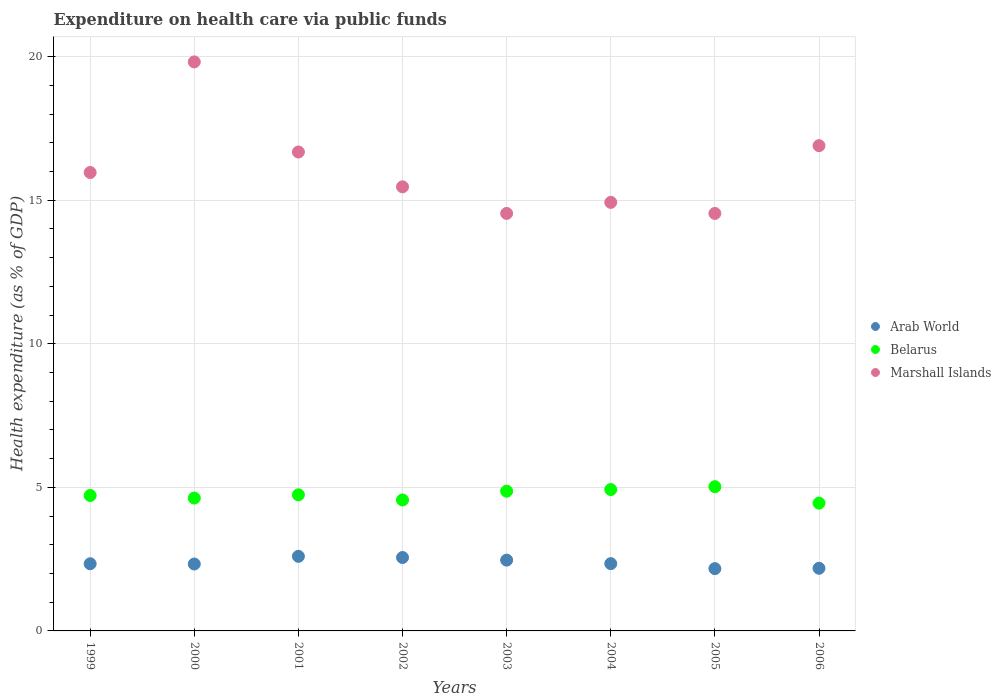How many different coloured dotlines are there?
Offer a terse response. 3. What is the expenditure made on health care in Marshall Islands in 2003?
Your answer should be very brief. 14.54. Across all years, what is the maximum expenditure made on health care in Belarus?
Offer a very short reply. 5.02. Across all years, what is the minimum expenditure made on health care in Belarus?
Ensure brevity in your answer.  4.45. In which year was the expenditure made on health care in Belarus maximum?
Your response must be concise. 2005. What is the total expenditure made on health care in Arab World in the graph?
Make the answer very short. 18.98. What is the difference between the expenditure made on health care in Arab World in 2005 and that in 2006?
Offer a very short reply. -0.01. What is the difference between the expenditure made on health care in Arab World in 2002 and the expenditure made on health care in Marshall Islands in 2001?
Your answer should be very brief. -14.12. What is the average expenditure made on health care in Arab World per year?
Offer a very short reply. 2.37. In the year 2004, what is the difference between the expenditure made on health care in Belarus and expenditure made on health care in Arab World?
Your answer should be very brief. 2.58. What is the ratio of the expenditure made on health care in Belarus in 2000 to that in 2004?
Provide a short and direct response. 0.94. What is the difference between the highest and the second highest expenditure made on health care in Belarus?
Keep it short and to the point. 0.1. What is the difference between the highest and the lowest expenditure made on health care in Arab World?
Offer a very short reply. 0.43. In how many years, is the expenditure made on health care in Belarus greater than the average expenditure made on health care in Belarus taken over all years?
Your response must be concise. 4. Is it the case that in every year, the sum of the expenditure made on health care in Arab World and expenditure made on health care in Belarus  is greater than the expenditure made on health care in Marshall Islands?
Offer a terse response. No. Is the expenditure made on health care in Marshall Islands strictly greater than the expenditure made on health care in Arab World over the years?
Give a very brief answer. Yes. Is the expenditure made on health care in Belarus strictly less than the expenditure made on health care in Marshall Islands over the years?
Give a very brief answer. Yes. How many dotlines are there?
Provide a succinct answer. 3. Are the values on the major ticks of Y-axis written in scientific E-notation?
Keep it short and to the point. No. Does the graph contain any zero values?
Your response must be concise. No. Does the graph contain grids?
Provide a short and direct response. Yes. Where does the legend appear in the graph?
Give a very brief answer. Center right. How many legend labels are there?
Keep it short and to the point. 3. What is the title of the graph?
Offer a very short reply. Expenditure on health care via public funds. Does "Norway" appear as one of the legend labels in the graph?
Give a very brief answer. No. What is the label or title of the X-axis?
Your response must be concise. Years. What is the label or title of the Y-axis?
Your answer should be very brief. Health expenditure (as % of GDP). What is the Health expenditure (as % of GDP) of Arab World in 1999?
Make the answer very short. 2.34. What is the Health expenditure (as % of GDP) of Belarus in 1999?
Provide a succinct answer. 4.72. What is the Health expenditure (as % of GDP) in Marshall Islands in 1999?
Offer a very short reply. 15.96. What is the Health expenditure (as % of GDP) of Arab World in 2000?
Offer a very short reply. 2.33. What is the Health expenditure (as % of GDP) in Belarus in 2000?
Offer a very short reply. 4.63. What is the Health expenditure (as % of GDP) in Marshall Islands in 2000?
Keep it short and to the point. 19.81. What is the Health expenditure (as % of GDP) of Arab World in 2001?
Make the answer very short. 2.6. What is the Health expenditure (as % of GDP) of Belarus in 2001?
Your response must be concise. 4.74. What is the Health expenditure (as % of GDP) of Marshall Islands in 2001?
Keep it short and to the point. 16.68. What is the Health expenditure (as % of GDP) of Arab World in 2002?
Give a very brief answer. 2.56. What is the Health expenditure (as % of GDP) in Belarus in 2002?
Make the answer very short. 4.56. What is the Health expenditure (as % of GDP) of Marshall Islands in 2002?
Your response must be concise. 15.46. What is the Health expenditure (as % of GDP) of Arab World in 2003?
Provide a succinct answer. 2.47. What is the Health expenditure (as % of GDP) in Belarus in 2003?
Offer a terse response. 4.87. What is the Health expenditure (as % of GDP) of Marshall Islands in 2003?
Make the answer very short. 14.54. What is the Health expenditure (as % of GDP) of Arab World in 2004?
Ensure brevity in your answer.  2.34. What is the Health expenditure (as % of GDP) of Belarus in 2004?
Your answer should be very brief. 4.92. What is the Health expenditure (as % of GDP) of Marshall Islands in 2004?
Your answer should be compact. 14.92. What is the Health expenditure (as % of GDP) of Arab World in 2005?
Provide a short and direct response. 2.17. What is the Health expenditure (as % of GDP) in Belarus in 2005?
Provide a succinct answer. 5.02. What is the Health expenditure (as % of GDP) of Marshall Islands in 2005?
Your answer should be very brief. 14.54. What is the Health expenditure (as % of GDP) of Arab World in 2006?
Your answer should be very brief. 2.18. What is the Health expenditure (as % of GDP) of Belarus in 2006?
Your answer should be compact. 4.45. What is the Health expenditure (as % of GDP) of Marshall Islands in 2006?
Make the answer very short. 16.9. Across all years, what is the maximum Health expenditure (as % of GDP) of Arab World?
Offer a very short reply. 2.6. Across all years, what is the maximum Health expenditure (as % of GDP) in Belarus?
Ensure brevity in your answer.  5.02. Across all years, what is the maximum Health expenditure (as % of GDP) of Marshall Islands?
Make the answer very short. 19.81. Across all years, what is the minimum Health expenditure (as % of GDP) in Arab World?
Keep it short and to the point. 2.17. Across all years, what is the minimum Health expenditure (as % of GDP) in Belarus?
Provide a short and direct response. 4.45. Across all years, what is the minimum Health expenditure (as % of GDP) in Marshall Islands?
Offer a terse response. 14.54. What is the total Health expenditure (as % of GDP) of Arab World in the graph?
Provide a succinct answer. 18.98. What is the total Health expenditure (as % of GDP) of Belarus in the graph?
Your answer should be very brief. 37.9. What is the total Health expenditure (as % of GDP) of Marshall Islands in the graph?
Your answer should be very brief. 128.82. What is the difference between the Health expenditure (as % of GDP) in Arab World in 1999 and that in 2000?
Offer a terse response. 0.01. What is the difference between the Health expenditure (as % of GDP) of Belarus in 1999 and that in 2000?
Keep it short and to the point. 0.09. What is the difference between the Health expenditure (as % of GDP) in Marshall Islands in 1999 and that in 2000?
Offer a terse response. -3.85. What is the difference between the Health expenditure (as % of GDP) in Arab World in 1999 and that in 2001?
Make the answer very short. -0.26. What is the difference between the Health expenditure (as % of GDP) in Belarus in 1999 and that in 2001?
Your answer should be very brief. -0.02. What is the difference between the Health expenditure (as % of GDP) in Marshall Islands in 1999 and that in 2001?
Provide a short and direct response. -0.71. What is the difference between the Health expenditure (as % of GDP) in Arab World in 1999 and that in 2002?
Your answer should be very brief. -0.22. What is the difference between the Health expenditure (as % of GDP) in Belarus in 1999 and that in 2002?
Offer a very short reply. 0.16. What is the difference between the Health expenditure (as % of GDP) in Marshall Islands in 1999 and that in 2002?
Offer a terse response. 0.5. What is the difference between the Health expenditure (as % of GDP) of Arab World in 1999 and that in 2003?
Offer a terse response. -0.13. What is the difference between the Health expenditure (as % of GDP) of Marshall Islands in 1999 and that in 2003?
Offer a very short reply. 1.43. What is the difference between the Health expenditure (as % of GDP) in Arab World in 1999 and that in 2004?
Give a very brief answer. -0. What is the difference between the Health expenditure (as % of GDP) in Belarus in 1999 and that in 2004?
Give a very brief answer. -0.21. What is the difference between the Health expenditure (as % of GDP) in Marshall Islands in 1999 and that in 2004?
Give a very brief answer. 1.04. What is the difference between the Health expenditure (as % of GDP) of Arab World in 1999 and that in 2005?
Ensure brevity in your answer.  0.17. What is the difference between the Health expenditure (as % of GDP) in Belarus in 1999 and that in 2005?
Provide a succinct answer. -0.31. What is the difference between the Health expenditure (as % of GDP) of Marshall Islands in 1999 and that in 2005?
Your answer should be compact. 1.43. What is the difference between the Health expenditure (as % of GDP) in Arab World in 1999 and that in 2006?
Offer a very short reply. 0.16. What is the difference between the Health expenditure (as % of GDP) in Belarus in 1999 and that in 2006?
Give a very brief answer. 0.27. What is the difference between the Health expenditure (as % of GDP) in Marshall Islands in 1999 and that in 2006?
Your answer should be compact. -0.93. What is the difference between the Health expenditure (as % of GDP) of Arab World in 2000 and that in 2001?
Your answer should be very brief. -0.27. What is the difference between the Health expenditure (as % of GDP) of Belarus in 2000 and that in 2001?
Keep it short and to the point. -0.11. What is the difference between the Health expenditure (as % of GDP) of Marshall Islands in 2000 and that in 2001?
Keep it short and to the point. 3.14. What is the difference between the Health expenditure (as % of GDP) in Arab World in 2000 and that in 2002?
Provide a short and direct response. -0.23. What is the difference between the Health expenditure (as % of GDP) of Belarus in 2000 and that in 2002?
Give a very brief answer. 0.07. What is the difference between the Health expenditure (as % of GDP) in Marshall Islands in 2000 and that in 2002?
Give a very brief answer. 4.35. What is the difference between the Health expenditure (as % of GDP) in Arab World in 2000 and that in 2003?
Ensure brevity in your answer.  -0.14. What is the difference between the Health expenditure (as % of GDP) in Belarus in 2000 and that in 2003?
Give a very brief answer. -0.24. What is the difference between the Health expenditure (as % of GDP) of Marshall Islands in 2000 and that in 2003?
Your answer should be very brief. 5.28. What is the difference between the Health expenditure (as % of GDP) of Arab World in 2000 and that in 2004?
Give a very brief answer. -0.01. What is the difference between the Health expenditure (as % of GDP) in Belarus in 2000 and that in 2004?
Your answer should be very brief. -0.3. What is the difference between the Health expenditure (as % of GDP) of Marshall Islands in 2000 and that in 2004?
Make the answer very short. 4.89. What is the difference between the Health expenditure (as % of GDP) in Arab World in 2000 and that in 2005?
Ensure brevity in your answer.  0.16. What is the difference between the Health expenditure (as % of GDP) of Belarus in 2000 and that in 2005?
Your answer should be compact. -0.4. What is the difference between the Health expenditure (as % of GDP) in Marshall Islands in 2000 and that in 2005?
Ensure brevity in your answer.  5.28. What is the difference between the Health expenditure (as % of GDP) of Arab World in 2000 and that in 2006?
Keep it short and to the point. 0.15. What is the difference between the Health expenditure (as % of GDP) of Belarus in 2000 and that in 2006?
Your response must be concise. 0.18. What is the difference between the Health expenditure (as % of GDP) of Marshall Islands in 2000 and that in 2006?
Your answer should be compact. 2.92. What is the difference between the Health expenditure (as % of GDP) in Arab World in 2001 and that in 2002?
Give a very brief answer. 0.04. What is the difference between the Health expenditure (as % of GDP) in Belarus in 2001 and that in 2002?
Your answer should be very brief. 0.18. What is the difference between the Health expenditure (as % of GDP) in Marshall Islands in 2001 and that in 2002?
Provide a short and direct response. 1.21. What is the difference between the Health expenditure (as % of GDP) of Arab World in 2001 and that in 2003?
Offer a very short reply. 0.13. What is the difference between the Health expenditure (as % of GDP) in Belarus in 2001 and that in 2003?
Keep it short and to the point. -0.13. What is the difference between the Health expenditure (as % of GDP) of Marshall Islands in 2001 and that in 2003?
Your answer should be compact. 2.14. What is the difference between the Health expenditure (as % of GDP) of Arab World in 2001 and that in 2004?
Give a very brief answer. 0.25. What is the difference between the Health expenditure (as % of GDP) of Belarus in 2001 and that in 2004?
Offer a terse response. -0.18. What is the difference between the Health expenditure (as % of GDP) of Marshall Islands in 2001 and that in 2004?
Make the answer very short. 1.75. What is the difference between the Health expenditure (as % of GDP) in Arab World in 2001 and that in 2005?
Provide a succinct answer. 0.43. What is the difference between the Health expenditure (as % of GDP) of Belarus in 2001 and that in 2005?
Ensure brevity in your answer.  -0.28. What is the difference between the Health expenditure (as % of GDP) of Marshall Islands in 2001 and that in 2005?
Ensure brevity in your answer.  2.14. What is the difference between the Health expenditure (as % of GDP) of Arab World in 2001 and that in 2006?
Your answer should be very brief. 0.42. What is the difference between the Health expenditure (as % of GDP) of Belarus in 2001 and that in 2006?
Offer a very short reply. 0.29. What is the difference between the Health expenditure (as % of GDP) of Marshall Islands in 2001 and that in 2006?
Give a very brief answer. -0.22. What is the difference between the Health expenditure (as % of GDP) of Arab World in 2002 and that in 2003?
Keep it short and to the point. 0.09. What is the difference between the Health expenditure (as % of GDP) of Belarus in 2002 and that in 2003?
Provide a short and direct response. -0.31. What is the difference between the Health expenditure (as % of GDP) of Marshall Islands in 2002 and that in 2003?
Ensure brevity in your answer.  0.93. What is the difference between the Health expenditure (as % of GDP) in Arab World in 2002 and that in 2004?
Keep it short and to the point. 0.21. What is the difference between the Health expenditure (as % of GDP) in Belarus in 2002 and that in 2004?
Your response must be concise. -0.36. What is the difference between the Health expenditure (as % of GDP) of Marshall Islands in 2002 and that in 2004?
Your answer should be very brief. 0.54. What is the difference between the Health expenditure (as % of GDP) of Arab World in 2002 and that in 2005?
Make the answer very short. 0.39. What is the difference between the Health expenditure (as % of GDP) of Belarus in 2002 and that in 2005?
Give a very brief answer. -0.46. What is the difference between the Health expenditure (as % of GDP) in Marshall Islands in 2002 and that in 2005?
Make the answer very short. 0.93. What is the difference between the Health expenditure (as % of GDP) of Arab World in 2002 and that in 2006?
Provide a succinct answer. 0.38. What is the difference between the Health expenditure (as % of GDP) of Belarus in 2002 and that in 2006?
Give a very brief answer. 0.11. What is the difference between the Health expenditure (as % of GDP) in Marshall Islands in 2002 and that in 2006?
Keep it short and to the point. -1.43. What is the difference between the Health expenditure (as % of GDP) in Arab World in 2003 and that in 2004?
Give a very brief answer. 0.12. What is the difference between the Health expenditure (as % of GDP) of Belarus in 2003 and that in 2004?
Your answer should be compact. -0.06. What is the difference between the Health expenditure (as % of GDP) of Marshall Islands in 2003 and that in 2004?
Keep it short and to the point. -0.38. What is the difference between the Health expenditure (as % of GDP) in Arab World in 2003 and that in 2005?
Offer a terse response. 0.3. What is the difference between the Health expenditure (as % of GDP) in Belarus in 2003 and that in 2005?
Offer a very short reply. -0.16. What is the difference between the Health expenditure (as % of GDP) of Marshall Islands in 2003 and that in 2005?
Give a very brief answer. -0. What is the difference between the Health expenditure (as % of GDP) in Arab World in 2003 and that in 2006?
Offer a terse response. 0.28. What is the difference between the Health expenditure (as % of GDP) of Belarus in 2003 and that in 2006?
Make the answer very short. 0.42. What is the difference between the Health expenditure (as % of GDP) of Marshall Islands in 2003 and that in 2006?
Provide a succinct answer. -2.36. What is the difference between the Health expenditure (as % of GDP) of Arab World in 2004 and that in 2005?
Your answer should be very brief. 0.17. What is the difference between the Health expenditure (as % of GDP) of Belarus in 2004 and that in 2005?
Ensure brevity in your answer.  -0.1. What is the difference between the Health expenditure (as % of GDP) of Marshall Islands in 2004 and that in 2005?
Give a very brief answer. 0.38. What is the difference between the Health expenditure (as % of GDP) in Arab World in 2004 and that in 2006?
Give a very brief answer. 0.16. What is the difference between the Health expenditure (as % of GDP) in Belarus in 2004 and that in 2006?
Offer a very short reply. 0.47. What is the difference between the Health expenditure (as % of GDP) of Marshall Islands in 2004 and that in 2006?
Keep it short and to the point. -1.97. What is the difference between the Health expenditure (as % of GDP) of Arab World in 2005 and that in 2006?
Provide a short and direct response. -0.01. What is the difference between the Health expenditure (as % of GDP) in Belarus in 2005 and that in 2006?
Ensure brevity in your answer.  0.57. What is the difference between the Health expenditure (as % of GDP) of Marshall Islands in 2005 and that in 2006?
Your response must be concise. -2.36. What is the difference between the Health expenditure (as % of GDP) of Arab World in 1999 and the Health expenditure (as % of GDP) of Belarus in 2000?
Your answer should be compact. -2.29. What is the difference between the Health expenditure (as % of GDP) in Arab World in 1999 and the Health expenditure (as % of GDP) in Marshall Islands in 2000?
Offer a very short reply. -17.48. What is the difference between the Health expenditure (as % of GDP) of Belarus in 1999 and the Health expenditure (as % of GDP) of Marshall Islands in 2000?
Provide a succinct answer. -15.1. What is the difference between the Health expenditure (as % of GDP) in Arab World in 1999 and the Health expenditure (as % of GDP) in Belarus in 2001?
Provide a succinct answer. -2.4. What is the difference between the Health expenditure (as % of GDP) of Arab World in 1999 and the Health expenditure (as % of GDP) of Marshall Islands in 2001?
Make the answer very short. -14.34. What is the difference between the Health expenditure (as % of GDP) of Belarus in 1999 and the Health expenditure (as % of GDP) of Marshall Islands in 2001?
Provide a short and direct response. -11.96. What is the difference between the Health expenditure (as % of GDP) in Arab World in 1999 and the Health expenditure (as % of GDP) in Belarus in 2002?
Offer a terse response. -2.22. What is the difference between the Health expenditure (as % of GDP) of Arab World in 1999 and the Health expenditure (as % of GDP) of Marshall Islands in 2002?
Offer a very short reply. -13.13. What is the difference between the Health expenditure (as % of GDP) of Belarus in 1999 and the Health expenditure (as % of GDP) of Marshall Islands in 2002?
Provide a short and direct response. -10.75. What is the difference between the Health expenditure (as % of GDP) of Arab World in 1999 and the Health expenditure (as % of GDP) of Belarus in 2003?
Provide a short and direct response. -2.53. What is the difference between the Health expenditure (as % of GDP) of Arab World in 1999 and the Health expenditure (as % of GDP) of Marshall Islands in 2003?
Offer a very short reply. -12.2. What is the difference between the Health expenditure (as % of GDP) in Belarus in 1999 and the Health expenditure (as % of GDP) in Marshall Islands in 2003?
Your response must be concise. -9.82. What is the difference between the Health expenditure (as % of GDP) of Arab World in 1999 and the Health expenditure (as % of GDP) of Belarus in 2004?
Offer a terse response. -2.58. What is the difference between the Health expenditure (as % of GDP) in Arab World in 1999 and the Health expenditure (as % of GDP) in Marshall Islands in 2004?
Your response must be concise. -12.58. What is the difference between the Health expenditure (as % of GDP) of Belarus in 1999 and the Health expenditure (as % of GDP) of Marshall Islands in 2004?
Keep it short and to the point. -10.21. What is the difference between the Health expenditure (as % of GDP) in Arab World in 1999 and the Health expenditure (as % of GDP) in Belarus in 2005?
Provide a short and direct response. -2.68. What is the difference between the Health expenditure (as % of GDP) of Arab World in 1999 and the Health expenditure (as % of GDP) of Marshall Islands in 2005?
Keep it short and to the point. -12.2. What is the difference between the Health expenditure (as % of GDP) in Belarus in 1999 and the Health expenditure (as % of GDP) in Marshall Islands in 2005?
Give a very brief answer. -9.82. What is the difference between the Health expenditure (as % of GDP) in Arab World in 1999 and the Health expenditure (as % of GDP) in Belarus in 2006?
Your response must be concise. -2.11. What is the difference between the Health expenditure (as % of GDP) of Arab World in 1999 and the Health expenditure (as % of GDP) of Marshall Islands in 2006?
Keep it short and to the point. -14.56. What is the difference between the Health expenditure (as % of GDP) in Belarus in 1999 and the Health expenditure (as % of GDP) in Marshall Islands in 2006?
Provide a succinct answer. -12.18. What is the difference between the Health expenditure (as % of GDP) of Arab World in 2000 and the Health expenditure (as % of GDP) of Belarus in 2001?
Your answer should be very brief. -2.41. What is the difference between the Health expenditure (as % of GDP) in Arab World in 2000 and the Health expenditure (as % of GDP) in Marshall Islands in 2001?
Give a very brief answer. -14.35. What is the difference between the Health expenditure (as % of GDP) of Belarus in 2000 and the Health expenditure (as % of GDP) of Marshall Islands in 2001?
Make the answer very short. -12.05. What is the difference between the Health expenditure (as % of GDP) of Arab World in 2000 and the Health expenditure (as % of GDP) of Belarus in 2002?
Keep it short and to the point. -2.23. What is the difference between the Health expenditure (as % of GDP) in Arab World in 2000 and the Health expenditure (as % of GDP) in Marshall Islands in 2002?
Your answer should be very brief. -13.13. What is the difference between the Health expenditure (as % of GDP) of Belarus in 2000 and the Health expenditure (as % of GDP) of Marshall Islands in 2002?
Offer a very short reply. -10.84. What is the difference between the Health expenditure (as % of GDP) of Arab World in 2000 and the Health expenditure (as % of GDP) of Belarus in 2003?
Provide a succinct answer. -2.54. What is the difference between the Health expenditure (as % of GDP) of Arab World in 2000 and the Health expenditure (as % of GDP) of Marshall Islands in 2003?
Provide a succinct answer. -12.21. What is the difference between the Health expenditure (as % of GDP) of Belarus in 2000 and the Health expenditure (as % of GDP) of Marshall Islands in 2003?
Make the answer very short. -9.91. What is the difference between the Health expenditure (as % of GDP) of Arab World in 2000 and the Health expenditure (as % of GDP) of Belarus in 2004?
Offer a very short reply. -2.59. What is the difference between the Health expenditure (as % of GDP) in Arab World in 2000 and the Health expenditure (as % of GDP) in Marshall Islands in 2004?
Offer a very short reply. -12.59. What is the difference between the Health expenditure (as % of GDP) of Belarus in 2000 and the Health expenditure (as % of GDP) of Marshall Islands in 2004?
Provide a short and direct response. -10.3. What is the difference between the Health expenditure (as % of GDP) in Arab World in 2000 and the Health expenditure (as % of GDP) in Belarus in 2005?
Offer a very short reply. -2.69. What is the difference between the Health expenditure (as % of GDP) of Arab World in 2000 and the Health expenditure (as % of GDP) of Marshall Islands in 2005?
Provide a short and direct response. -12.21. What is the difference between the Health expenditure (as % of GDP) in Belarus in 2000 and the Health expenditure (as % of GDP) in Marshall Islands in 2005?
Make the answer very short. -9.91. What is the difference between the Health expenditure (as % of GDP) in Arab World in 2000 and the Health expenditure (as % of GDP) in Belarus in 2006?
Offer a very short reply. -2.12. What is the difference between the Health expenditure (as % of GDP) in Arab World in 2000 and the Health expenditure (as % of GDP) in Marshall Islands in 2006?
Ensure brevity in your answer.  -14.57. What is the difference between the Health expenditure (as % of GDP) of Belarus in 2000 and the Health expenditure (as % of GDP) of Marshall Islands in 2006?
Keep it short and to the point. -12.27. What is the difference between the Health expenditure (as % of GDP) in Arab World in 2001 and the Health expenditure (as % of GDP) in Belarus in 2002?
Your answer should be compact. -1.96. What is the difference between the Health expenditure (as % of GDP) of Arab World in 2001 and the Health expenditure (as % of GDP) of Marshall Islands in 2002?
Offer a very short reply. -12.87. What is the difference between the Health expenditure (as % of GDP) of Belarus in 2001 and the Health expenditure (as % of GDP) of Marshall Islands in 2002?
Ensure brevity in your answer.  -10.72. What is the difference between the Health expenditure (as % of GDP) of Arab World in 2001 and the Health expenditure (as % of GDP) of Belarus in 2003?
Your response must be concise. -2.27. What is the difference between the Health expenditure (as % of GDP) of Arab World in 2001 and the Health expenditure (as % of GDP) of Marshall Islands in 2003?
Give a very brief answer. -11.94. What is the difference between the Health expenditure (as % of GDP) of Belarus in 2001 and the Health expenditure (as % of GDP) of Marshall Islands in 2003?
Ensure brevity in your answer.  -9.8. What is the difference between the Health expenditure (as % of GDP) of Arab World in 2001 and the Health expenditure (as % of GDP) of Belarus in 2004?
Your response must be concise. -2.33. What is the difference between the Health expenditure (as % of GDP) of Arab World in 2001 and the Health expenditure (as % of GDP) of Marshall Islands in 2004?
Keep it short and to the point. -12.33. What is the difference between the Health expenditure (as % of GDP) of Belarus in 2001 and the Health expenditure (as % of GDP) of Marshall Islands in 2004?
Offer a very short reply. -10.18. What is the difference between the Health expenditure (as % of GDP) in Arab World in 2001 and the Health expenditure (as % of GDP) in Belarus in 2005?
Provide a succinct answer. -2.43. What is the difference between the Health expenditure (as % of GDP) of Arab World in 2001 and the Health expenditure (as % of GDP) of Marshall Islands in 2005?
Offer a terse response. -11.94. What is the difference between the Health expenditure (as % of GDP) in Belarus in 2001 and the Health expenditure (as % of GDP) in Marshall Islands in 2005?
Give a very brief answer. -9.8. What is the difference between the Health expenditure (as % of GDP) of Arab World in 2001 and the Health expenditure (as % of GDP) of Belarus in 2006?
Your response must be concise. -1.85. What is the difference between the Health expenditure (as % of GDP) in Arab World in 2001 and the Health expenditure (as % of GDP) in Marshall Islands in 2006?
Give a very brief answer. -14.3. What is the difference between the Health expenditure (as % of GDP) of Belarus in 2001 and the Health expenditure (as % of GDP) of Marshall Islands in 2006?
Offer a terse response. -12.16. What is the difference between the Health expenditure (as % of GDP) in Arab World in 2002 and the Health expenditure (as % of GDP) in Belarus in 2003?
Your answer should be compact. -2.31. What is the difference between the Health expenditure (as % of GDP) in Arab World in 2002 and the Health expenditure (as % of GDP) in Marshall Islands in 2003?
Ensure brevity in your answer.  -11.98. What is the difference between the Health expenditure (as % of GDP) in Belarus in 2002 and the Health expenditure (as % of GDP) in Marshall Islands in 2003?
Provide a succinct answer. -9.98. What is the difference between the Health expenditure (as % of GDP) in Arab World in 2002 and the Health expenditure (as % of GDP) in Belarus in 2004?
Your answer should be very brief. -2.37. What is the difference between the Health expenditure (as % of GDP) in Arab World in 2002 and the Health expenditure (as % of GDP) in Marshall Islands in 2004?
Give a very brief answer. -12.37. What is the difference between the Health expenditure (as % of GDP) of Belarus in 2002 and the Health expenditure (as % of GDP) of Marshall Islands in 2004?
Offer a terse response. -10.36. What is the difference between the Health expenditure (as % of GDP) in Arab World in 2002 and the Health expenditure (as % of GDP) in Belarus in 2005?
Provide a short and direct response. -2.47. What is the difference between the Health expenditure (as % of GDP) in Arab World in 2002 and the Health expenditure (as % of GDP) in Marshall Islands in 2005?
Provide a short and direct response. -11.98. What is the difference between the Health expenditure (as % of GDP) in Belarus in 2002 and the Health expenditure (as % of GDP) in Marshall Islands in 2005?
Provide a succinct answer. -9.98. What is the difference between the Health expenditure (as % of GDP) of Arab World in 2002 and the Health expenditure (as % of GDP) of Belarus in 2006?
Your answer should be compact. -1.89. What is the difference between the Health expenditure (as % of GDP) in Arab World in 2002 and the Health expenditure (as % of GDP) in Marshall Islands in 2006?
Provide a succinct answer. -14.34. What is the difference between the Health expenditure (as % of GDP) in Belarus in 2002 and the Health expenditure (as % of GDP) in Marshall Islands in 2006?
Provide a succinct answer. -12.34. What is the difference between the Health expenditure (as % of GDP) of Arab World in 2003 and the Health expenditure (as % of GDP) of Belarus in 2004?
Your response must be concise. -2.46. What is the difference between the Health expenditure (as % of GDP) of Arab World in 2003 and the Health expenditure (as % of GDP) of Marshall Islands in 2004?
Provide a short and direct response. -12.46. What is the difference between the Health expenditure (as % of GDP) of Belarus in 2003 and the Health expenditure (as % of GDP) of Marshall Islands in 2004?
Your answer should be compact. -10.06. What is the difference between the Health expenditure (as % of GDP) in Arab World in 2003 and the Health expenditure (as % of GDP) in Belarus in 2005?
Provide a short and direct response. -2.56. What is the difference between the Health expenditure (as % of GDP) in Arab World in 2003 and the Health expenditure (as % of GDP) in Marshall Islands in 2005?
Give a very brief answer. -12.07. What is the difference between the Health expenditure (as % of GDP) in Belarus in 2003 and the Health expenditure (as % of GDP) in Marshall Islands in 2005?
Your response must be concise. -9.67. What is the difference between the Health expenditure (as % of GDP) of Arab World in 2003 and the Health expenditure (as % of GDP) of Belarus in 2006?
Ensure brevity in your answer.  -1.98. What is the difference between the Health expenditure (as % of GDP) of Arab World in 2003 and the Health expenditure (as % of GDP) of Marshall Islands in 2006?
Your response must be concise. -14.43. What is the difference between the Health expenditure (as % of GDP) in Belarus in 2003 and the Health expenditure (as % of GDP) in Marshall Islands in 2006?
Your answer should be compact. -12.03. What is the difference between the Health expenditure (as % of GDP) in Arab World in 2004 and the Health expenditure (as % of GDP) in Belarus in 2005?
Offer a terse response. -2.68. What is the difference between the Health expenditure (as % of GDP) in Arab World in 2004 and the Health expenditure (as % of GDP) in Marshall Islands in 2005?
Offer a very short reply. -12.2. What is the difference between the Health expenditure (as % of GDP) of Belarus in 2004 and the Health expenditure (as % of GDP) of Marshall Islands in 2005?
Ensure brevity in your answer.  -9.62. What is the difference between the Health expenditure (as % of GDP) in Arab World in 2004 and the Health expenditure (as % of GDP) in Belarus in 2006?
Ensure brevity in your answer.  -2.11. What is the difference between the Health expenditure (as % of GDP) in Arab World in 2004 and the Health expenditure (as % of GDP) in Marshall Islands in 2006?
Offer a very short reply. -14.55. What is the difference between the Health expenditure (as % of GDP) in Belarus in 2004 and the Health expenditure (as % of GDP) in Marshall Islands in 2006?
Ensure brevity in your answer.  -11.97. What is the difference between the Health expenditure (as % of GDP) of Arab World in 2005 and the Health expenditure (as % of GDP) of Belarus in 2006?
Offer a terse response. -2.28. What is the difference between the Health expenditure (as % of GDP) in Arab World in 2005 and the Health expenditure (as % of GDP) in Marshall Islands in 2006?
Provide a short and direct response. -14.73. What is the difference between the Health expenditure (as % of GDP) in Belarus in 2005 and the Health expenditure (as % of GDP) in Marshall Islands in 2006?
Keep it short and to the point. -11.88. What is the average Health expenditure (as % of GDP) of Arab World per year?
Your answer should be very brief. 2.37. What is the average Health expenditure (as % of GDP) in Belarus per year?
Your answer should be very brief. 4.74. What is the average Health expenditure (as % of GDP) of Marshall Islands per year?
Your answer should be very brief. 16.1. In the year 1999, what is the difference between the Health expenditure (as % of GDP) in Arab World and Health expenditure (as % of GDP) in Belarus?
Ensure brevity in your answer.  -2.38. In the year 1999, what is the difference between the Health expenditure (as % of GDP) in Arab World and Health expenditure (as % of GDP) in Marshall Islands?
Offer a very short reply. -13.62. In the year 1999, what is the difference between the Health expenditure (as % of GDP) of Belarus and Health expenditure (as % of GDP) of Marshall Islands?
Ensure brevity in your answer.  -11.25. In the year 2000, what is the difference between the Health expenditure (as % of GDP) in Arab World and Health expenditure (as % of GDP) in Belarus?
Keep it short and to the point. -2.3. In the year 2000, what is the difference between the Health expenditure (as % of GDP) in Arab World and Health expenditure (as % of GDP) in Marshall Islands?
Offer a terse response. -17.48. In the year 2000, what is the difference between the Health expenditure (as % of GDP) in Belarus and Health expenditure (as % of GDP) in Marshall Islands?
Your answer should be compact. -15.19. In the year 2001, what is the difference between the Health expenditure (as % of GDP) of Arab World and Health expenditure (as % of GDP) of Belarus?
Keep it short and to the point. -2.14. In the year 2001, what is the difference between the Health expenditure (as % of GDP) of Arab World and Health expenditure (as % of GDP) of Marshall Islands?
Keep it short and to the point. -14.08. In the year 2001, what is the difference between the Health expenditure (as % of GDP) of Belarus and Health expenditure (as % of GDP) of Marshall Islands?
Your answer should be compact. -11.94. In the year 2002, what is the difference between the Health expenditure (as % of GDP) of Arab World and Health expenditure (as % of GDP) of Belarus?
Your answer should be compact. -2. In the year 2002, what is the difference between the Health expenditure (as % of GDP) of Arab World and Health expenditure (as % of GDP) of Marshall Islands?
Keep it short and to the point. -12.91. In the year 2002, what is the difference between the Health expenditure (as % of GDP) in Belarus and Health expenditure (as % of GDP) in Marshall Islands?
Your answer should be very brief. -10.9. In the year 2003, what is the difference between the Health expenditure (as % of GDP) of Arab World and Health expenditure (as % of GDP) of Belarus?
Make the answer very short. -2.4. In the year 2003, what is the difference between the Health expenditure (as % of GDP) in Arab World and Health expenditure (as % of GDP) in Marshall Islands?
Provide a succinct answer. -12.07. In the year 2003, what is the difference between the Health expenditure (as % of GDP) of Belarus and Health expenditure (as % of GDP) of Marshall Islands?
Provide a short and direct response. -9.67. In the year 2004, what is the difference between the Health expenditure (as % of GDP) in Arab World and Health expenditure (as % of GDP) in Belarus?
Your answer should be compact. -2.58. In the year 2004, what is the difference between the Health expenditure (as % of GDP) of Arab World and Health expenditure (as % of GDP) of Marshall Islands?
Ensure brevity in your answer.  -12.58. In the year 2005, what is the difference between the Health expenditure (as % of GDP) of Arab World and Health expenditure (as % of GDP) of Belarus?
Provide a succinct answer. -2.85. In the year 2005, what is the difference between the Health expenditure (as % of GDP) of Arab World and Health expenditure (as % of GDP) of Marshall Islands?
Keep it short and to the point. -12.37. In the year 2005, what is the difference between the Health expenditure (as % of GDP) of Belarus and Health expenditure (as % of GDP) of Marshall Islands?
Give a very brief answer. -9.52. In the year 2006, what is the difference between the Health expenditure (as % of GDP) of Arab World and Health expenditure (as % of GDP) of Belarus?
Ensure brevity in your answer.  -2.27. In the year 2006, what is the difference between the Health expenditure (as % of GDP) of Arab World and Health expenditure (as % of GDP) of Marshall Islands?
Offer a very short reply. -14.72. In the year 2006, what is the difference between the Health expenditure (as % of GDP) of Belarus and Health expenditure (as % of GDP) of Marshall Islands?
Provide a short and direct response. -12.45. What is the ratio of the Health expenditure (as % of GDP) in Arab World in 1999 to that in 2000?
Offer a terse response. 1. What is the ratio of the Health expenditure (as % of GDP) of Belarus in 1999 to that in 2000?
Provide a succinct answer. 1.02. What is the ratio of the Health expenditure (as % of GDP) in Marshall Islands in 1999 to that in 2000?
Keep it short and to the point. 0.81. What is the ratio of the Health expenditure (as % of GDP) of Arab World in 1999 to that in 2001?
Your response must be concise. 0.9. What is the ratio of the Health expenditure (as % of GDP) of Belarus in 1999 to that in 2001?
Offer a very short reply. 0.99. What is the ratio of the Health expenditure (as % of GDP) in Marshall Islands in 1999 to that in 2001?
Provide a succinct answer. 0.96. What is the ratio of the Health expenditure (as % of GDP) of Arab World in 1999 to that in 2002?
Your answer should be very brief. 0.92. What is the ratio of the Health expenditure (as % of GDP) of Belarus in 1999 to that in 2002?
Your answer should be very brief. 1.03. What is the ratio of the Health expenditure (as % of GDP) in Marshall Islands in 1999 to that in 2002?
Ensure brevity in your answer.  1.03. What is the ratio of the Health expenditure (as % of GDP) of Arab World in 1999 to that in 2003?
Offer a very short reply. 0.95. What is the ratio of the Health expenditure (as % of GDP) of Belarus in 1999 to that in 2003?
Your response must be concise. 0.97. What is the ratio of the Health expenditure (as % of GDP) in Marshall Islands in 1999 to that in 2003?
Provide a succinct answer. 1.1. What is the ratio of the Health expenditure (as % of GDP) in Arab World in 1999 to that in 2004?
Provide a short and direct response. 1. What is the ratio of the Health expenditure (as % of GDP) in Belarus in 1999 to that in 2004?
Give a very brief answer. 0.96. What is the ratio of the Health expenditure (as % of GDP) in Marshall Islands in 1999 to that in 2004?
Your answer should be compact. 1.07. What is the ratio of the Health expenditure (as % of GDP) of Arab World in 1999 to that in 2005?
Offer a very short reply. 1.08. What is the ratio of the Health expenditure (as % of GDP) of Belarus in 1999 to that in 2005?
Offer a very short reply. 0.94. What is the ratio of the Health expenditure (as % of GDP) in Marshall Islands in 1999 to that in 2005?
Your answer should be compact. 1.1. What is the ratio of the Health expenditure (as % of GDP) in Arab World in 1999 to that in 2006?
Offer a terse response. 1.07. What is the ratio of the Health expenditure (as % of GDP) of Belarus in 1999 to that in 2006?
Provide a succinct answer. 1.06. What is the ratio of the Health expenditure (as % of GDP) in Marshall Islands in 1999 to that in 2006?
Ensure brevity in your answer.  0.94. What is the ratio of the Health expenditure (as % of GDP) of Arab World in 2000 to that in 2001?
Give a very brief answer. 0.9. What is the ratio of the Health expenditure (as % of GDP) of Belarus in 2000 to that in 2001?
Your response must be concise. 0.98. What is the ratio of the Health expenditure (as % of GDP) in Marshall Islands in 2000 to that in 2001?
Provide a short and direct response. 1.19. What is the ratio of the Health expenditure (as % of GDP) of Arab World in 2000 to that in 2002?
Give a very brief answer. 0.91. What is the ratio of the Health expenditure (as % of GDP) of Belarus in 2000 to that in 2002?
Offer a terse response. 1.01. What is the ratio of the Health expenditure (as % of GDP) in Marshall Islands in 2000 to that in 2002?
Provide a succinct answer. 1.28. What is the ratio of the Health expenditure (as % of GDP) of Arab World in 2000 to that in 2003?
Make the answer very short. 0.94. What is the ratio of the Health expenditure (as % of GDP) of Belarus in 2000 to that in 2003?
Offer a terse response. 0.95. What is the ratio of the Health expenditure (as % of GDP) in Marshall Islands in 2000 to that in 2003?
Keep it short and to the point. 1.36. What is the ratio of the Health expenditure (as % of GDP) in Belarus in 2000 to that in 2004?
Your response must be concise. 0.94. What is the ratio of the Health expenditure (as % of GDP) of Marshall Islands in 2000 to that in 2004?
Your answer should be very brief. 1.33. What is the ratio of the Health expenditure (as % of GDP) in Arab World in 2000 to that in 2005?
Offer a terse response. 1.07. What is the ratio of the Health expenditure (as % of GDP) in Belarus in 2000 to that in 2005?
Ensure brevity in your answer.  0.92. What is the ratio of the Health expenditure (as % of GDP) in Marshall Islands in 2000 to that in 2005?
Keep it short and to the point. 1.36. What is the ratio of the Health expenditure (as % of GDP) of Arab World in 2000 to that in 2006?
Ensure brevity in your answer.  1.07. What is the ratio of the Health expenditure (as % of GDP) in Belarus in 2000 to that in 2006?
Keep it short and to the point. 1.04. What is the ratio of the Health expenditure (as % of GDP) in Marshall Islands in 2000 to that in 2006?
Keep it short and to the point. 1.17. What is the ratio of the Health expenditure (as % of GDP) of Arab World in 2001 to that in 2002?
Your answer should be compact. 1.02. What is the ratio of the Health expenditure (as % of GDP) in Belarus in 2001 to that in 2002?
Your answer should be very brief. 1.04. What is the ratio of the Health expenditure (as % of GDP) of Marshall Islands in 2001 to that in 2002?
Your response must be concise. 1.08. What is the ratio of the Health expenditure (as % of GDP) in Arab World in 2001 to that in 2003?
Give a very brief answer. 1.05. What is the ratio of the Health expenditure (as % of GDP) of Belarus in 2001 to that in 2003?
Ensure brevity in your answer.  0.97. What is the ratio of the Health expenditure (as % of GDP) of Marshall Islands in 2001 to that in 2003?
Offer a terse response. 1.15. What is the ratio of the Health expenditure (as % of GDP) in Arab World in 2001 to that in 2004?
Ensure brevity in your answer.  1.11. What is the ratio of the Health expenditure (as % of GDP) in Belarus in 2001 to that in 2004?
Your response must be concise. 0.96. What is the ratio of the Health expenditure (as % of GDP) of Marshall Islands in 2001 to that in 2004?
Your answer should be compact. 1.12. What is the ratio of the Health expenditure (as % of GDP) of Arab World in 2001 to that in 2005?
Provide a succinct answer. 1.2. What is the ratio of the Health expenditure (as % of GDP) in Belarus in 2001 to that in 2005?
Keep it short and to the point. 0.94. What is the ratio of the Health expenditure (as % of GDP) in Marshall Islands in 2001 to that in 2005?
Offer a very short reply. 1.15. What is the ratio of the Health expenditure (as % of GDP) of Arab World in 2001 to that in 2006?
Provide a short and direct response. 1.19. What is the ratio of the Health expenditure (as % of GDP) in Belarus in 2001 to that in 2006?
Your response must be concise. 1.07. What is the ratio of the Health expenditure (as % of GDP) of Marshall Islands in 2001 to that in 2006?
Give a very brief answer. 0.99. What is the ratio of the Health expenditure (as % of GDP) in Arab World in 2002 to that in 2003?
Ensure brevity in your answer.  1.04. What is the ratio of the Health expenditure (as % of GDP) in Belarus in 2002 to that in 2003?
Your answer should be compact. 0.94. What is the ratio of the Health expenditure (as % of GDP) of Marshall Islands in 2002 to that in 2003?
Ensure brevity in your answer.  1.06. What is the ratio of the Health expenditure (as % of GDP) of Arab World in 2002 to that in 2004?
Give a very brief answer. 1.09. What is the ratio of the Health expenditure (as % of GDP) of Belarus in 2002 to that in 2004?
Offer a terse response. 0.93. What is the ratio of the Health expenditure (as % of GDP) of Marshall Islands in 2002 to that in 2004?
Your answer should be very brief. 1.04. What is the ratio of the Health expenditure (as % of GDP) in Arab World in 2002 to that in 2005?
Provide a short and direct response. 1.18. What is the ratio of the Health expenditure (as % of GDP) in Belarus in 2002 to that in 2005?
Provide a short and direct response. 0.91. What is the ratio of the Health expenditure (as % of GDP) in Marshall Islands in 2002 to that in 2005?
Your response must be concise. 1.06. What is the ratio of the Health expenditure (as % of GDP) in Arab World in 2002 to that in 2006?
Provide a succinct answer. 1.17. What is the ratio of the Health expenditure (as % of GDP) of Belarus in 2002 to that in 2006?
Provide a short and direct response. 1.02. What is the ratio of the Health expenditure (as % of GDP) in Marshall Islands in 2002 to that in 2006?
Your response must be concise. 0.92. What is the ratio of the Health expenditure (as % of GDP) in Arab World in 2003 to that in 2004?
Keep it short and to the point. 1.05. What is the ratio of the Health expenditure (as % of GDP) in Belarus in 2003 to that in 2004?
Offer a terse response. 0.99. What is the ratio of the Health expenditure (as % of GDP) in Marshall Islands in 2003 to that in 2004?
Give a very brief answer. 0.97. What is the ratio of the Health expenditure (as % of GDP) in Arab World in 2003 to that in 2005?
Make the answer very short. 1.14. What is the ratio of the Health expenditure (as % of GDP) in Belarus in 2003 to that in 2005?
Provide a succinct answer. 0.97. What is the ratio of the Health expenditure (as % of GDP) in Marshall Islands in 2003 to that in 2005?
Provide a succinct answer. 1. What is the ratio of the Health expenditure (as % of GDP) in Arab World in 2003 to that in 2006?
Give a very brief answer. 1.13. What is the ratio of the Health expenditure (as % of GDP) of Belarus in 2003 to that in 2006?
Provide a succinct answer. 1.09. What is the ratio of the Health expenditure (as % of GDP) of Marshall Islands in 2003 to that in 2006?
Provide a short and direct response. 0.86. What is the ratio of the Health expenditure (as % of GDP) of Belarus in 2004 to that in 2005?
Provide a short and direct response. 0.98. What is the ratio of the Health expenditure (as % of GDP) in Marshall Islands in 2004 to that in 2005?
Provide a succinct answer. 1.03. What is the ratio of the Health expenditure (as % of GDP) of Arab World in 2004 to that in 2006?
Keep it short and to the point. 1.07. What is the ratio of the Health expenditure (as % of GDP) in Belarus in 2004 to that in 2006?
Offer a very short reply. 1.11. What is the ratio of the Health expenditure (as % of GDP) of Marshall Islands in 2004 to that in 2006?
Your answer should be compact. 0.88. What is the ratio of the Health expenditure (as % of GDP) in Belarus in 2005 to that in 2006?
Give a very brief answer. 1.13. What is the ratio of the Health expenditure (as % of GDP) in Marshall Islands in 2005 to that in 2006?
Give a very brief answer. 0.86. What is the difference between the highest and the second highest Health expenditure (as % of GDP) of Arab World?
Offer a very short reply. 0.04. What is the difference between the highest and the second highest Health expenditure (as % of GDP) in Belarus?
Keep it short and to the point. 0.1. What is the difference between the highest and the second highest Health expenditure (as % of GDP) in Marshall Islands?
Keep it short and to the point. 2.92. What is the difference between the highest and the lowest Health expenditure (as % of GDP) of Arab World?
Your answer should be very brief. 0.43. What is the difference between the highest and the lowest Health expenditure (as % of GDP) of Belarus?
Keep it short and to the point. 0.57. What is the difference between the highest and the lowest Health expenditure (as % of GDP) of Marshall Islands?
Keep it short and to the point. 5.28. 